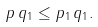<formula> <loc_0><loc_0><loc_500><loc_500>\| p \, q \| _ { 1 } \leq \| p \| _ { 1 } \, \| q \| _ { 1 } .</formula> 